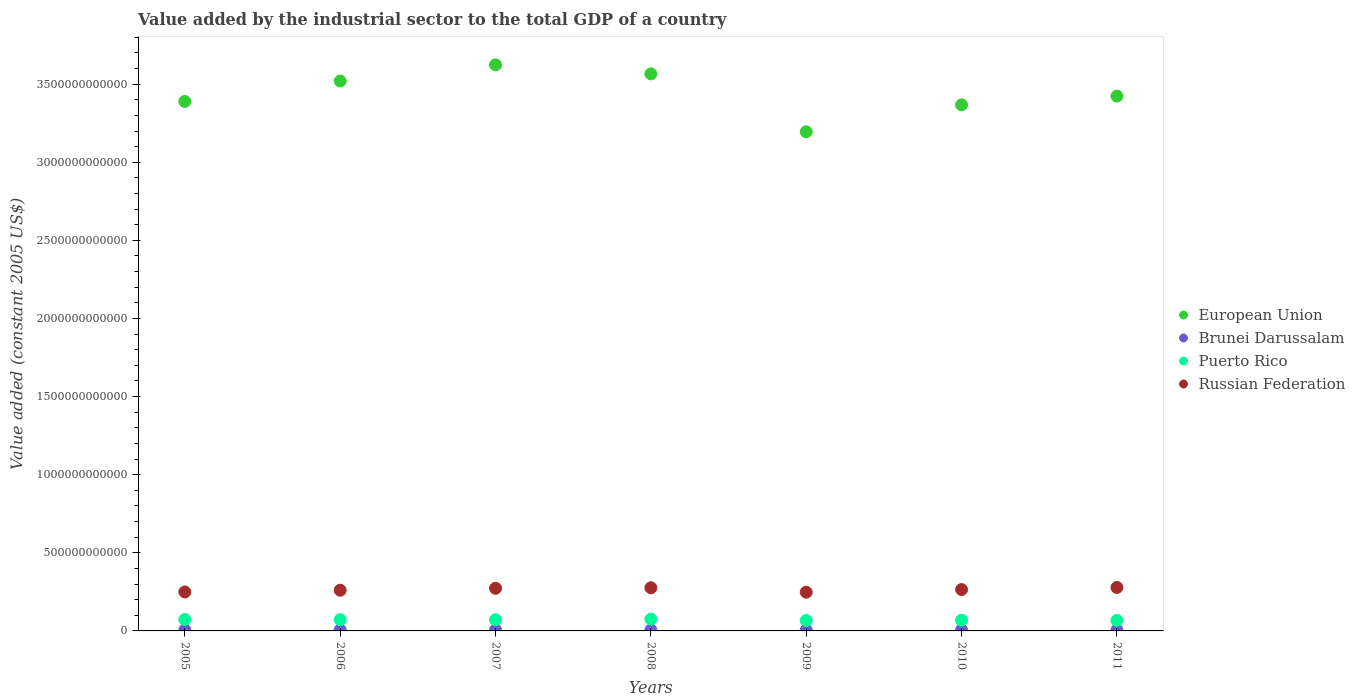What is the value added by the industrial sector in Brunei Darussalam in 2005?
Give a very brief answer. 6.82e+09. Across all years, what is the maximum value added by the industrial sector in Brunei Darussalam?
Offer a very short reply. 7.02e+09. Across all years, what is the minimum value added by the industrial sector in Brunei Darussalam?
Offer a terse response. 5.95e+09. In which year was the value added by the industrial sector in European Union minimum?
Your response must be concise. 2009. What is the total value added by the industrial sector in Puerto Rico in the graph?
Ensure brevity in your answer.  4.94e+11. What is the difference between the value added by the industrial sector in Brunei Darussalam in 2005 and that in 2010?
Give a very brief answer. 7.68e+08. What is the difference between the value added by the industrial sector in Puerto Rico in 2011 and the value added by the industrial sector in European Union in 2007?
Provide a short and direct response. -3.56e+12. What is the average value added by the industrial sector in Brunei Darussalam per year?
Ensure brevity in your answer.  6.42e+09. In the year 2011, what is the difference between the value added by the industrial sector in Russian Federation and value added by the industrial sector in Brunei Darussalam?
Provide a short and direct response. 2.72e+11. In how many years, is the value added by the industrial sector in Brunei Darussalam greater than 3700000000000 US$?
Your response must be concise. 0. What is the ratio of the value added by the industrial sector in European Union in 2008 to that in 2010?
Offer a terse response. 1.06. What is the difference between the highest and the second highest value added by the industrial sector in Russian Federation?
Offer a very short reply. 1.80e+09. What is the difference between the highest and the lowest value added by the industrial sector in Puerto Rico?
Provide a succinct answer. 9.23e+09. In how many years, is the value added by the industrial sector in European Union greater than the average value added by the industrial sector in European Union taken over all years?
Keep it short and to the point. 3. Is the sum of the value added by the industrial sector in Brunei Darussalam in 2008 and 2011 greater than the maximum value added by the industrial sector in Puerto Rico across all years?
Ensure brevity in your answer.  No. Is it the case that in every year, the sum of the value added by the industrial sector in Puerto Rico and value added by the industrial sector in Russian Federation  is greater than the sum of value added by the industrial sector in European Union and value added by the industrial sector in Brunei Darussalam?
Your response must be concise. Yes. Is it the case that in every year, the sum of the value added by the industrial sector in Russian Federation and value added by the industrial sector in European Union  is greater than the value added by the industrial sector in Brunei Darussalam?
Your answer should be very brief. Yes. Is the value added by the industrial sector in Brunei Darussalam strictly greater than the value added by the industrial sector in Puerto Rico over the years?
Keep it short and to the point. No. What is the difference between two consecutive major ticks on the Y-axis?
Your answer should be compact. 5.00e+11. Are the values on the major ticks of Y-axis written in scientific E-notation?
Offer a terse response. No. Does the graph contain any zero values?
Give a very brief answer. No. Does the graph contain grids?
Your answer should be very brief. No. Where does the legend appear in the graph?
Offer a terse response. Center right. How many legend labels are there?
Keep it short and to the point. 4. How are the legend labels stacked?
Make the answer very short. Vertical. What is the title of the graph?
Give a very brief answer. Value added by the industrial sector to the total GDP of a country. What is the label or title of the X-axis?
Provide a succinct answer. Years. What is the label or title of the Y-axis?
Ensure brevity in your answer.  Value added (constant 2005 US$). What is the Value added (constant 2005 US$) of European Union in 2005?
Your response must be concise. 3.39e+12. What is the Value added (constant 2005 US$) in Brunei Darussalam in 2005?
Your answer should be compact. 6.82e+09. What is the Value added (constant 2005 US$) in Puerto Rico in 2005?
Offer a very short reply. 7.31e+1. What is the Value added (constant 2005 US$) of Russian Federation in 2005?
Ensure brevity in your answer.  2.49e+11. What is the Value added (constant 2005 US$) of European Union in 2006?
Keep it short and to the point. 3.52e+12. What is the Value added (constant 2005 US$) in Brunei Darussalam in 2006?
Your answer should be very brief. 7.02e+09. What is the Value added (constant 2005 US$) in Puerto Rico in 2006?
Ensure brevity in your answer.  7.20e+1. What is the Value added (constant 2005 US$) in Russian Federation in 2006?
Your answer should be compact. 2.60e+11. What is the Value added (constant 2005 US$) of European Union in 2007?
Provide a succinct answer. 3.62e+12. What is the Value added (constant 2005 US$) in Brunei Darussalam in 2007?
Your response must be concise. 6.62e+09. What is the Value added (constant 2005 US$) in Puerto Rico in 2007?
Offer a terse response. 7.10e+1. What is the Value added (constant 2005 US$) of Russian Federation in 2007?
Ensure brevity in your answer.  2.73e+11. What is the Value added (constant 2005 US$) of European Union in 2008?
Provide a succinct answer. 3.57e+12. What is the Value added (constant 2005 US$) of Brunei Darussalam in 2008?
Provide a succinct answer. 6.26e+09. What is the Value added (constant 2005 US$) in Puerto Rico in 2008?
Ensure brevity in your answer.  7.57e+1. What is the Value added (constant 2005 US$) in Russian Federation in 2008?
Your answer should be very brief. 2.76e+11. What is the Value added (constant 2005 US$) of European Union in 2009?
Provide a succinct answer. 3.19e+12. What is the Value added (constant 2005 US$) of Brunei Darussalam in 2009?
Offer a very short reply. 5.95e+09. What is the Value added (constant 2005 US$) in Puerto Rico in 2009?
Offer a terse response. 6.65e+1. What is the Value added (constant 2005 US$) of Russian Federation in 2009?
Your response must be concise. 2.48e+11. What is the Value added (constant 2005 US$) of European Union in 2010?
Give a very brief answer. 3.37e+12. What is the Value added (constant 2005 US$) in Brunei Darussalam in 2010?
Provide a short and direct response. 6.05e+09. What is the Value added (constant 2005 US$) of Puerto Rico in 2010?
Your response must be concise. 6.83e+1. What is the Value added (constant 2005 US$) in Russian Federation in 2010?
Your answer should be compact. 2.65e+11. What is the Value added (constant 2005 US$) in European Union in 2011?
Provide a succinct answer. 3.42e+12. What is the Value added (constant 2005 US$) in Brunei Darussalam in 2011?
Provide a short and direct response. 6.25e+09. What is the Value added (constant 2005 US$) of Puerto Rico in 2011?
Make the answer very short. 6.72e+1. What is the Value added (constant 2005 US$) in Russian Federation in 2011?
Provide a succinct answer. 2.78e+11. Across all years, what is the maximum Value added (constant 2005 US$) of European Union?
Your answer should be compact. 3.62e+12. Across all years, what is the maximum Value added (constant 2005 US$) in Brunei Darussalam?
Your answer should be very brief. 7.02e+09. Across all years, what is the maximum Value added (constant 2005 US$) of Puerto Rico?
Offer a very short reply. 7.57e+1. Across all years, what is the maximum Value added (constant 2005 US$) in Russian Federation?
Give a very brief answer. 2.78e+11. Across all years, what is the minimum Value added (constant 2005 US$) of European Union?
Give a very brief answer. 3.19e+12. Across all years, what is the minimum Value added (constant 2005 US$) of Brunei Darussalam?
Give a very brief answer. 5.95e+09. Across all years, what is the minimum Value added (constant 2005 US$) in Puerto Rico?
Your response must be concise. 6.65e+1. Across all years, what is the minimum Value added (constant 2005 US$) of Russian Federation?
Offer a terse response. 2.48e+11. What is the total Value added (constant 2005 US$) of European Union in the graph?
Provide a succinct answer. 2.41e+13. What is the total Value added (constant 2005 US$) of Brunei Darussalam in the graph?
Provide a short and direct response. 4.50e+1. What is the total Value added (constant 2005 US$) of Puerto Rico in the graph?
Provide a short and direct response. 4.94e+11. What is the total Value added (constant 2005 US$) in Russian Federation in the graph?
Your response must be concise. 1.85e+12. What is the difference between the Value added (constant 2005 US$) in European Union in 2005 and that in 2006?
Keep it short and to the point. -1.31e+11. What is the difference between the Value added (constant 2005 US$) in Brunei Darussalam in 2005 and that in 2006?
Your response must be concise. -1.95e+08. What is the difference between the Value added (constant 2005 US$) of Puerto Rico in 2005 and that in 2006?
Offer a terse response. 1.15e+09. What is the difference between the Value added (constant 2005 US$) of Russian Federation in 2005 and that in 2006?
Offer a very short reply. -1.12e+1. What is the difference between the Value added (constant 2005 US$) in European Union in 2005 and that in 2007?
Make the answer very short. -2.35e+11. What is the difference between the Value added (constant 2005 US$) in Brunei Darussalam in 2005 and that in 2007?
Ensure brevity in your answer.  1.96e+08. What is the difference between the Value added (constant 2005 US$) in Puerto Rico in 2005 and that in 2007?
Make the answer very short. 2.08e+09. What is the difference between the Value added (constant 2005 US$) in Russian Federation in 2005 and that in 2007?
Provide a succinct answer. -2.37e+1. What is the difference between the Value added (constant 2005 US$) in European Union in 2005 and that in 2008?
Your answer should be very brief. -1.77e+11. What is the difference between the Value added (constant 2005 US$) in Brunei Darussalam in 2005 and that in 2008?
Give a very brief answer. 5.57e+08. What is the difference between the Value added (constant 2005 US$) in Puerto Rico in 2005 and that in 2008?
Your response must be concise. -2.58e+09. What is the difference between the Value added (constant 2005 US$) in Russian Federation in 2005 and that in 2008?
Offer a terse response. -2.70e+1. What is the difference between the Value added (constant 2005 US$) in European Union in 2005 and that in 2009?
Provide a short and direct response. 1.94e+11. What is the difference between the Value added (constant 2005 US$) in Brunei Darussalam in 2005 and that in 2009?
Provide a succinct answer. 8.71e+08. What is the difference between the Value added (constant 2005 US$) in Puerto Rico in 2005 and that in 2009?
Your answer should be very brief. 6.65e+09. What is the difference between the Value added (constant 2005 US$) of Russian Federation in 2005 and that in 2009?
Make the answer very short. 1.47e+09. What is the difference between the Value added (constant 2005 US$) of European Union in 2005 and that in 2010?
Offer a terse response. 2.17e+1. What is the difference between the Value added (constant 2005 US$) in Brunei Darussalam in 2005 and that in 2010?
Provide a short and direct response. 7.68e+08. What is the difference between the Value added (constant 2005 US$) in Puerto Rico in 2005 and that in 2010?
Ensure brevity in your answer.  4.78e+09. What is the difference between the Value added (constant 2005 US$) of Russian Federation in 2005 and that in 2010?
Give a very brief answer. -1.53e+1. What is the difference between the Value added (constant 2005 US$) of European Union in 2005 and that in 2011?
Your answer should be very brief. -3.43e+1. What is the difference between the Value added (constant 2005 US$) in Brunei Darussalam in 2005 and that in 2011?
Your answer should be compact. 5.75e+08. What is the difference between the Value added (constant 2005 US$) of Puerto Rico in 2005 and that in 2011?
Give a very brief answer. 5.91e+09. What is the difference between the Value added (constant 2005 US$) of Russian Federation in 2005 and that in 2011?
Your answer should be very brief. -2.88e+1. What is the difference between the Value added (constant 2005 US$) in European Union in 2006 and that in 2007?
Your response must be concise. -1.04e+11. What is the difference between the Value added (constant 2005 US$) of Brunei Darussalam in 2006 and that in 2007?
Give a very brief answer. 3.91e+08. What is the difference between the Value added (constant 2005 US$) in Puerto Rico in 2006 and that in 2007?
Keep it short and to the point. 9.25e+08. What is the difference between the Value added (constant 2005 US$) of Russian Federation in 2006 and that in 2007?
Give a very brief answer. -1.25e+1. What is the difference between the Value added (constant 2005 US$) in European Union in 2006 and that in 2008?
Your response must be concise. -4.59e+1. What is the difference between the Value added (constant 2005 US$) of Brunei Darussalam in 2006 and that in 2008?
Keep it short and to the point. 7.51e+08. What is the difference between the Value added (constant 2005 US$) in Puerto Rico in 2006 and that in 2008?
Your answer should be compact. -3.73e+09. What is the difference between the Value added (constant 2005 US$) of Russian Federation in 2006 and that in 2008?
Your answer should be very brief. -1.58e+1. What is the difference between the Value added (constant 2005 US$) of European Union in 2006 and that in 2009?
Your answer should be compact. 3.25e+11. What is the difference between the Value added (constant 2005 US$) in Brunei Darussalam in 2006 and that in 2009?
Provide a succinct answer. 1.07e+09. What is the difference between the Value added (constant 2005 US$) of Puerto Rico in 2006 and that in 2009?
Offer a very short reply. 5.50e+09. What is the difference between the Value added (constant 2005 US$) of Russian Federation in 2006 and that in 2009?
Your answer should be compact. 1.27e+1. What is the difference between the Value added (constant 2005 US$) of European Union in 2006 and that in 2010?
Offer a terse response. 1.53e+11. What is the difference between the Value added (constant 2005 US$) in Brunei Darussalam in 2006 and that in 2010?
Give a very brief answer. 9.63e+08. What is the difference between the Value added (constant 2005 US$) of Puerto Rico in 2006 and that in 2010?
Provide a short and direct response. 3.63e+09. What is the difference between the Value added (constant 2005 US$) in Russian Federation in 2006 and that in 2010?
Give a very brief answer. -4.16e+09. What is the difference between the Value added (constant 2005 US$) in European Union in 2006 and that in 2011?
Provide a short and direct response. 9.66e+1. What is the difference between the Value added (constant 2005 US$) of Brunei Darussalam in 2006 and that in 2011?
Ensure brevity in your answer.  7.70e+08. What is the difference between the Value added (constant 2005 US$) of Puerto Rico in 2006 and that in 2011?
Keep it short and to the point. 4.76e+09. What is the difference between the Value added (constant 2005 US$) in Russian Federation in 2006 and that in 2011?
Your answer should be very brief. -1.76e+1. What is the difference between the Value added (constant 2005 US$) in European Union in 2007 and that in 2008?
Your answer should be very brief. 5.77e+1. What is the difference between the Value added (constant 2005 US$) of Brunei Darussalam in 2007 and that in 2008?
Give a very brief answer. 3.60e+08. What is the difference between the Value added (constant 2005 US$) in Puerto Rico in 2007 and that in 2008?
Make the answer very short. -4.65e+09. What is the difference between the Value added (constant 2005 US$) in Russian Federation in 2007 and that in 2008?
Make the answer very short. -3.32e+09. What is the difference between the Value added (constant 2005 US$) of European Union in 2007 and that in 2009?
Make the answer very short. 4.29e+11. What is the difference between the Value added (constant 2005 US$) of Brunei Darussalam in 2007 and that in 2009?
Provide a short and direct response. 6.75e+08. What is the difference between the Value added (constant 2005 US$) in Puerto Rico in 2007 and that in 2009?
Your answer should be very brief. 4.57e+09. What is the difference between the Value added (constant 2005 US$) in Russian Federation in 2007 and that in 2009?
Provide a short and direct response. 2.52e+1. What is the difference between the Value added (constant 2005 US$) of European Union in 2007 and that in 2010?
Offer a very short reply. 2.56e+11. What is the difference between the Value added (constant 2005 US$) of Brunei Darussalam in 2007 and that in 2010?
Ensure brevity in your answer.  5.72e+08. What is the difference between the Value added (constant 2005 US$) of Puerto Rico in 2007 and that in 2010?
Offer a terse response. 2.70e+09. What is the difference between the Value added (constant 2005 US$) in Russian Federation in 2007 and that in 2010?
Your answer should be compact. 8.37e+09. What is the difference between the Value added (constant 2005 US$) of European Union in 2007 and that in 2011?
Your answer should be very brief. 2.00e+11. What is the difference between the Value added (constant 2005 US$) of Brunei Darussalam in 2007 and that in 2011?
Offer a terse response. 3.79e+08. What is the difference between the Value added (constant 2005 US$) in Puerto Rico in 2007 and that in 2011?
Offer a terse response. 3.84e+09. What is the difference between the Value added (constant 2005 US$) in Russian Federation in 2007 and that in 2011?
Offer a very short reply. -5.12e+09. What is the difference between the Value added (constant 2005 US$) of European Union in 2008 and that in 2009?
Give a very brief answer. 3.71e+11. What is the difference between the Value added (constant 2005 US$) of Brunei Darussalam in 2008 and that in 2009?
Offer a very short reply. 3.14e+08. What is the difference between the Value added (constant 2005 US$) in Puerto Rico in 2008 and that in 2009?
Keep it short and to the point. 9.23e+09. What is the difference between the Value added (constant 2005 US$) in Russian Federation in 2008 and that in 2009?
Make the answer very short. 2.85e+1. What is the difference between the Value added (constant 2005 US$) in European Union in 2008 and that in 2010?
Offer a very short reply. 1.98e+11. What is the difference between the Value added (constant 2005 US$) of Brunei Darussalam in 2008 and that in 2010?
Your response must be concise. 2.12e+08. What is the difference between the Value added (constant 2005 US$) in Puerto Rico in 2008 and that in 2010?
Your answer should be very brief. 7.36e+09. What is the difference between the Value added (constant 2005 US$) in Russian Federation in 2008 and that in 2010?
Give a very brief answer. 1.17e+1. What is the difference between the Value added (constant 2005 US$) of European Union in 2008 and that in 2011?
Offer a very short reply. 1.42e+11. What is the difference between the Value added (constant 2005 US$) in Brunei Darussalam in 2008 and that in 2011?
Your response must be concise. 1.89e+07. What is the difference between the Value added (constant 2005 US$) in Puerto Rico in 2008 and that in 2011?
Your answer should be compact. 8.49e+09. What is the difference between the Value added (constant 2005 US$) in Russian Federation in 2008 and that in 2011?
Provide a short and direct response. -1.80e+09. What is the difference between the Value added (constant 2005 US$) of European Union in 2009 and that in 2010?
Provide a short and direct response. -1.72e+11. What is the difference between the Value added (constant 2005 US$) in Brunei Darussalam in 2009 and that in 2010?
Ensure brevity in your answer.  -1.03e+08. What is the difference between the Value added (constant 2005 US$) of Puerto Rico in 2009 and that in 2010?
Your answer should be compact. -1.87e+09. What is the difference between the Value added (constant 2005 US$) of Russian Federation in 2009 and that in 2010?
Your answer should be compact. -1.68e+1. What is the difference between the Value added (constant 2005 US$) of European Union in 2009 and that in 2011?
Your answer should be very brief. -2.28e+11. What is the difference between the Value added (constant 2005 US$) of Brunei Darussalam in 2009 and that in 2011?
Your answer should be compact. -2.95e+08. What is the difference between the Value added (constant 2005 US$) of Puerto Rico in 2009 and that in 2011?
Your answer should be compact. -7.33e+08. What is the difference between the Value added (constant 2005 US$) in Russian Federation in 2009 and that in 2011?
Offer a very short reply. -3.03e+1. What is the difference between the Value added (constant 2005 US$) in European Union in 2010 and that in 2011?
Your answer should be compact. -5.60e+1. What is the difference between the Value added (constant 2005 US$) in Brunei Darussalam in 2010 and that in 2011?
Offer a very short reply. -1.93e+08. What is the difference between the Value added (constant 2005 US$) in Puerto Rico in 2010 and that in 2011?
Give a very brief answer. 1.13e+09. What is the difference between the Value added (constant 2005 US$) of Russian Federation in 2010 and that in 2011?
Provide a succinct answer. -1.35e+1. What is the difference between the Value added (constant 2005 US$) in European Union in 2005 and the Value added (constant 2005 US$) in Brunei Darussalam in 2006?
Your response must be concise. 3.38e+12. What is the difference between the Value added (constant 2005 US$) in European Union in 2005 and the Value added (constant 2005 US$) in Puerto Rico in 2006?
Make the answer very short. 3.32e+12. What is the difference between the Value added (constant 2005 US$) of European Union in 2005 and the Value added (constant 2005 US$) of Russian Federation in 2006?
Make the answer very short. 3.13e+12. What is the difference between the Value added (constant 2005 US$) in Brunei Darussalam in 2005 and the Value added (constant 2005 US$) in Puerto Rico in 2006?
Make the answer very short. -6.51e+1. What is the difference between the Value added (constant 2005 US$) in Brunei Darussalam in 2005 and the Value added (constant 2005 US$) in Russian Federation in 2006?
Ensure brevity in your answer.  -2.54e+11. What is the difference between the Value added (constant 2005 US$) in Puerto Rico in 2005 and the Value added (constant 2005 US$) in Russian Federation in 2006?
Give a very brief answer. -1.87e+11. What is the difference between the Value added (constant 2005 US$) in European Union in 2005 and the Value added (constant 2005 US$) in Brunei Darussalam in 2007?
Offer a very short reply. 3.38e+12. What is the difference between the Value added (constant 2005 US$) of European Union in 2005 and the Value added (constant 2005 US$) of Puerto Rico in 2007?
Offer a terse response. 3.32e+12. What is the difference between the Value added (constant 2005 US$) of European Union in 2005 and the Value added (constant 2005 US$) of Russian Federation in 2007?
Offer a very short reply. 3.12e+12. What is the difference between the Value added (constant 2005 US$) in Brunei Darussalam in 2005 and the Value added (constant 2005 US$) in Puerto Rico in 2007?
Keep it short and to the point. -6.42e+1. What is the difference between the Value added (constant 2005 US$) of Brunei Darussalam in 2005 and the Value added (constant 2005 US$) of Russian Federation in 2007?
Give a very brief answer. -2.66e+11. What is the difference between the Value added (constant 2005 US$) in Puerto Rico in 2005 and the Value added (constant 2005 US$) in Russian Federation in 2007?
Your response must be concise. -2.00e+11. What is the difference between the Value added (constant 2005 US$) of European Union in 2005 and the Value added (constant 2005 US$) of Brunei Darussalam in 2008?
Your response must be concise. 3.38e+12. What is the difference between the Value added (constant 2005 US$) in European Union in 2005 and the Value added (constant 2005 US$) in Puerto Rico in 2008?
Provide a succinct answer. 3.31e+12. What is the difference between the Value added (constant 2005 US$) in European Union in 2005 and the Value added (constant 2005 US$) in Russian Federation in 2008?
Provide a short and direct response. 3.11e+12. What is the difference between the Value added (constant 2005 US$) in Brunei Darussalam in 2005 and the Value added (constant 2005 US$) in Puerto Rico in 2008?
Keep it short and to the point. -6.89e+1. What is the difference between the Value added (constant 2005 US$) in Brunei Darussalam in 2005 and the Value added (constant 2005 US$) in Russian Federation in 2008?
Give a very brief answer. -2.69e+11. What is the difference between the Value added (constant 2005 US$) in Puerto Rico in 2005 and the Value added (constant 2005 US$) in Russian Federation in 2008?
Ensure brevity in your answer.  -2.03e+11. What is the difference between the Value added (constant 2005 US$) in European Union in 2005 and the Value added (constant 2005 US$) in Brunei Darussalam in 2009?
Your answer should be very brief. 3.38e+12. What is the difference between the Value added (constant 2005 US$) of European Union in 2005 and the Value added (constant 2005 US$) of Puerto Rico in 2009?
Keep it short and to the point. 3.32e+12. What is the difference between the Value added (constant 2005 US$) in European Union in 2005 and the Value added (constant 2005 US$) in Russian Federation in 2009?
Your answer should be very brief. 3.14e+12. What is the difference between the Value added (constant 2005 US$) of Brunei Darussalam in 2005 and the Value added (constant 2005 US$) of Puerto Rico in 2009?
Provide a short and direct response. -5.96e+1. What is the difference between the Value added (constant 2005 US$) of Brunei Darussalam in 2005 and the Value added (constant 2005 US$) of Russian Federation in 2009?
Your response must be concise. -2.41e+11. What is the difference between the Value added (constant 2005 US$) of Puerto Rico in 2005 and the Value added (constant 2005 US$) of Russian Federation in 2009?
Provide a short and direct response. -1.75e+11. What is the difference between the Value added (constant 2005 US$) in European Union in 2005 and the Value added (constant 2005 US$) in Brunei Darussalam in 2010?
Offer a very short reply. 3.38e+12. What is the difference between the Value added (constant 2005 US$) of European Union in 2005 and the Value added (constant 2005 US$) of Puerto Rico in 2010?
Provide a succinct answer. 3.32e+12. What is the difference between the Value added (constant 2005 US$) in European Union in 2005 and the Value added (constant 2005 US$) in Russian Federation in 2010?
Make the answer very short. 3.12e+12. What is the difference between the Value added (constant 2005 US$) in Brunei Darussalam in 2005 and the Value added (constant 2005 US$) in Puerto Rico in 2010?
Offer a very short reply. -6.15e+1. What is the difference between the Value added (constant 2005 US$) of Brunei Darussalam in 2005 and the Value added (constant 2005 US$) of Russian Federation in 2010?
Give a very brief answer. -2.58e+11. What is the difference between the Value added (constant 2005 US$) of Puerto Rico in 2005 and the Value added (constant 2005 US$) of Russian Federation in 2010?
Provide a succinct answer. -1.92e+11. What is the difference between the Value added (constant 2005 US$) in European Union in 2005 and the Value added (constant 2005 US$) in Brunei Darussalam in 2011?
Keep it short and to the point. 3.38e+12. What is the difference between the Value added (constant 2005 US$) in European Union in 2005 and the Value added (constant 2005 US$) in Puerto Rico in 2011?
Offer a very short reply. 3.32e+12. What is the difference between the Value added (constant 2005 US$) in European Union in 2005 and the Value added (constant 2005 US$) in Russian Federation in 2011?
Your answer should be compact. 3.11e+12. What is the difference between the Value added (constant 2005 US$) in Brunei Darussalam in 2005 and the Value added (constant 2005 US$) in Puerto Rico in 2011?
Your answer should be compact. -6.04e+1. What is the difference between the Value added (constant 2005 US$) in Brunei Darussalam in 2005 and the Value added (constant 2005 US$) in Russian Federation in 2011?
Offer a very short reply. -2.71e+11. What is the difference between the Value added (constant 2005 US$) in Puerto Rico in 2005 and the Value added (constant 2005 US$) in Russian Federation in 2011?
Make the answer very short. -2.05e+11. What is the difference between the Value added (constant 2005 US$) of European Union in 2006 and the Value added (constant 2005 US$) of Brunei Darussalam in 2007?
Offer a very short reply. 3.51e+12. What is the difference between the Value added (constant 2005 US$) of European Union in 2006 and the Value added (constant 2005 US$) of Puerto Rico in 2007?
Offer a terse response. 3.45e+12. What is the difference between the Value added (constant 2005 US$) of European Union in 2006 and the Value added (constant 2005 US$) of Russian Federation in 2007?
Keep it short and to the point. 3.25e+12. What is the difference between the Value added (constant 2005 US$) in Brunei Darussalam in 2006 and the Value added (constant 2005 US$) in Puerto Rico in 2007?
Make the answer very short. -6.40e+1. What is the difference between the Value added (constant 2005 US$) of Brunei Darussalam in 2006 and the Value added (constant 2005 US$) of Russian Federation in 2007?
Your response must be concise. -2.66e+11. What is the difference between the Value added (constant 2005 US$) of Puerto Rico in 2006 and the Value added (constant 2005 US$) of Russian Federation in 2007?
Ensure brevity in your answer.  -2.01e+11. What is the difference between the Value added (constant 2005 US$) in European Union in 2006 and the Value added (constant 2005 US$) in Brunei Darussalam in 2008?
Your answer should be compact. 3.51e+12. What is the difference between the Value added (constant 2005 US$) of European Union in 2006 and the Value added (constant 2005 US$) of Puerto Rico in 2008?
Offer a very short reply. 3.44e+12. What is the difference between the Value added (constant 2005 US$) of European Union in 2006 and the Value added (constant 2005 US$) of Russian Federation in 2008?
Keep it short and to the point. 3.24e+12. What is the difference between the Value added (constant 2005 US$) of Brunei Darussalam in 2006 and the Value added (constant 2005 US$) of Puerto Rico in 2008?
Offer a terse response. -6.87e+1. What is the difference between the Value added (constant 2005 US$) in Brunei Darussalam in 2006 and the Value added (constant 2005 US$) in Russian Federation in 2008?
Your answer should be compact. -2.69e+11. What is the difference between the Value added (constant 2005 US$) in Puerto Rico in 2006 and the Value added (constant 2005 US$) in Russian Federation in 2008?
Your response must be concise. -2.04e+11. What is the difference between the Value added (constant 2005 US$) in European Union in 2006 and the Value added (constant 2005 US$) in Brunei Darussalam in 2009?
Your answer should be compact. 3.51e+12. What is the difference between the Value added (constant 2005 US$) in European Union in 2006 and the Value added (constant 2005 US$) in Puerto Rico in 2009?
Ensure brevity in your answer.  3.45e+12. What is the difference between the Value added (constant 2005 US$) in European Union in 2006 and the Value added (constant 2005 US$) in Russian Federation in 2009?
Keep it short and to the point. 3.27e+12. What is the difference between the Value added (constant 2005 US$) in Brunei Darussalam in 2006 and the Value added (constant 2005 US$) in Puerto Rico in 2009?
Provide a succinct answer. -5.95e+1. What is the difference between the Value added (constant 2005 US$) of Brunei Darussalam in 2006 and the Value added (constant 2005 US$) of Russian Federation in 2009?
Provide a short and direct response. -2.41e+11. What is the difference between the Value added (constant 2005 US$) of Puerto Rico in 2006 and the Value added (constant 2005 US$) of Russian Federation in 2009?
Provide a succinct answer. -1.76e+11. What is the difference between the Value added (constant 2005 US$) of European Union in 2006 and the Value added (constant 2005 US$) of Brunei Darussalam in 2010?
Your answer should be compact. 3.51e+12. What is the difference between the Value added (constant 2005 US$) of European Union in 2006 and the Value added (constant 2005 US$) of Puerto Rico in 2010?
Give a very brief answer. 3.45e+12. What is the difference between the Value added (constant 2005 US$) in European Union in 2006 and the Value added (constant 2005 US$) in Russian Federation in 2010?
Give a very brief answer. 3.26e+12. What is the difference between the Value added (constant 2005 US$) of Brunei Darussalam in 2006 and the Value added (constant 2005 US$) of Puerto Rico in 2010?
Ensure brevity in your answer.  -6.13e+1. What is the difference between the Value added (constant 2005 US$) of Brunei Darussalam in 2006 and the Value added (constant 2005 US$) of Russian Federation in 2010?
Your answer should be compact. -2.58e+11. What is the difference between the Value added (constant 2005 US$) in Puerto Rico in 2006 and the Value added (constant 2005 US$) in Russian Federation in 2010?
Make the answer very short. -1.93e+11. What is the difference between the Value added (constant 2005 US$) in European Union in 2006 and the Value added (constant 2005 US$) in Brunei Darussalam in 2011?
Your answer should be compact. 3.51e+12. What is the difference between the Value added (constant 2005 US$) in European Union in 2006 and the Value added (constant 2005 US$) in Puerto Rico in 2011?
Keep it short and to the point. 3.45e+12. What is the difference between the Value added (constant 2005 US$) in European Union in 2006 and the Value added (constant 2005 US$) in Russian Federation in 2011?
Your answer should be compact. 3.24e+12. What is the difference between the Value added (constant 2005 US$) in Brunei Darussalam in 2006 and the Value added (constant 2005 US$) in Puerto Rico in 2011?
Give a very brief answer. -6.02e+1. What is the difference between the Value added (constant 2005 US$) in Brunei Darussalam in 2006 and the Value added (constant 2005 US$) in Russian Federation in 2011?
Keep it short and to the point. -2.71e+11. What is the difference between the Value added (constant 2005 US$) of Puerto Rico in 2006 and the Value added (constant 2005 US$) of Russian Federation in 2011?
Provide a short and direct response. -2.06e+11. What is the difference between the Value added (constant 2005 US$) in European Union in 2007 and the Value added (constant 2005 US$) in Brunei Darussalam in 2008?
Give a very brief answer. 3.62e+12. What is the difference between the Value added (constant 2005 US$) in European Union in 2007 and the Value added (constant 2005 US$) in Puerto Rico in 2008?
Your answer should be very brief. 3.55e+12. What is the difference between the Value added (constant 2005 US$) of European Union in 2007 and the Value added (constant 2005 US$) of Russian Federation in 2008?
Make the answer very short. 3.35e+12. What is the difference between the Value added (constant 2005 US$) of Brunei Darussalam in 2007 and the Value added (constant 2005 US$) of Puerto Rico in 2008?
Your answer should be compact. -6.91e+1. What is the difference between the Value added (constant 2005 US$) in Brunei Darussalam in 2007 and the Value added (constant 2005 US$) in Russian Federation in 2008?
Keep it short and to the point. -2.70e+11. What is the difference between the Value added (constant 2005 US$) in Puerto Rico in 2007 and the Value added (constant 2005 US$) in Russian Federation in 2008?
Offer a very short reply. -2.05e+11. What is the difference between the Value added (constant 2005 US$) in European Union in 2007 and the Value added (constant 2005 US$) in Brunei Darussalam in 2009?
Make the answer very short. 3.62e+12. What is the difference between the Value added (constant 2005 US$) of European Union in 2007 and the Value added (constant 2005 US$) of Puerto Rico in 2009?
Ensure brevity in your answer.  3.56e+12. What is the difference between the Value added (constant 2005 US$) in European Union in 2007 and the Value added (constant 2005 US$) in Russian Federation in 2009?
Make the answer very short. 3.38e+12. What is the difference between the Value added (constant 2005 US$) in Brunei Darussalam in 2007 and the Value added (constant 2005 US$) in Puerto Rico in 2009?
Give a very brief answer. -5.98e+1. What is the difference between the Value added (constant 2005 US$) of Brunei Darussalam in 2007 and the Value added (constant 2005 US$) of Russian Federation in 2009?
Offer a terse response. -2.41e+11. What is the difference between the Value added (constant 2005 US$) in Puerto Rico in 2007 and the Value added (constant 2005 US$) in Russian Federation in 2009?
Provide a short and direct response. -1.77e+11. What is the difference between the Value added (constant 2005 US$) of European Union in 2007 and the Value added (constant 2005 US$) of Brunei Darussalam in 2010?
Provide a short and direct response. 3.62e+12. What is the difference between the Value added (constant 2005 US$) in European Union in 2007 and the Value added (constant 2005 US$) in Puerto Rico in 2010?
Offer a very short reply. 3.56e+12. What is the difference between the Value added (constant 2005 US$) in European Union in 2007 and the Value added (constant 2005 US$) in Russian Federation in 2010?
Make the answer very short. 3.36e+12. What is the difference between the Value added (constant 2005 US$) of Brunei Darussalam in 2007 and the Value added (constant 2005 US$) of Puerto Rico in 2010?
Give a very brief answer. -6.17e+1. What is the difference between the Value added (constant 2005 US$) of Brunei Darussalam in 2007 and the Value added (constant 2005 US$) of Russian Federation in 2010?
Provide a short and direct response. -2.58e+11. What is the difference between the Value added (constant 2005 US$) of Puerto Rico in 2007 and the Value added (constant 2005 US$) of Russian Federation in 2010?
Your answer should be compact. -1.94e+11. What is the difference between the Value added (constant 2005 US$) in European Union in 2007 and the Value added (constant 2005 US$) in Brunei Darussalam in 2011?
Ensure brevity in your answer.  3.62e+12. What is the difference between the Value added (constant 2005 US$) in European Union in 2007 and the Value added (constant 2005 US$) in Puerto Rico in 2011?
Offer a very short reply. 3.56e+12. What is the difference between the Value added (constant 2005 US$) of European Union in 2007 and the Value added (constant 2005 US$) of Russian Federation in 2011?
Your answer should be compact. 3.35e+12. What is the difference between the Value added (constant 2005 US$) of Brunei Darussalam in 2007 and the Value added (constant 2005 US$) of Puerto Rico in 2011?
Offer a terse response. -6.06e+1. What is the difference between the Value added (constant 2005 US$) in Brunei Darussalam in 2007 and the Value added (constant 2005 US$) in Russian Federation in 2011?
Make the answer very short. -2.71e+11. What is the difference between the Value added (constant 2005 US$) in Puerto Rico in 2007 and the Value added (constant 2005 US$) in Russian Federation in 2011?
Your answer should be very brief. -2.07e+11. What is the difference between the Value added (constant 2005 US$) in European Union in 2008 and the Value added (constant 2005 US$) in Brunei Darussalam in 2009?
Give a very brief answer. 3.56e+12. What is the difference between the Value added (constant 2005 US$) of European Union in 2008 and the Value added (constant 2005 US$) of Puerto Rico in 2009?
Your answer should be very brief. 3.50e+12. What is the difference between the Value added (constant 2005 US$) of European Union in 2008 and the Value added (constant 2005 US$) of Russian Federation in 2009?
Ensure brevity in your answer.  3.32e+12. What is the difference between the Value added (constant 2005 US$) of Brunei Darussalam in 2008 and the Value added (constant 2005 US$) of Puerto Rico in 2009?
Offer a terse response. -6.02e+1. What is the difference between the Value added (constant 2005 US$) in Brunei Darussalam in 2008 and the Value added (constant 2005 US$) in Russian Federation in 2009?
Make the answer very short. -2.42e+11. What is the difference between the Value added (constant 2005 US$) in Puerto Rico in 2008 and the Value added (constant 2005 US$) in Russian Federation in 2009?
Ensure brevity in your answer.  -1.72e+11. What is the difference between the Value added (constant 2005 US$) of European Union in 2008 and the Value added (constant 2005 US$) of Brunei Darussalam in 2010?
Provide a succinct answer. 3.56e+12. What is the difference between the Value added (constant 2005 US$) in European Union in 2008 and the Value added (constant 2005 US$) in Puerto Rico in 2010?
Your answer should be very brief. 3.50e+12. What is the difference between the Value added (constant 2005 US$) of European Union in 2008 and the Value added (constant 2005 US$) of Russian Federation in 2010?
Offer a terse response. 3.30e+12. What is the difference between the Value added (constant 2005 US$) of Brunei Darussalam in 2008 and the Value added (constant 2005 US$) of Puerto Rico in 2010?
Your response must be concise. -6.21e+1. What is the difference between the Value added (constant 2005 US$) in Brunei Darussalam in 2008 and the Value added (constant 2005 US$) in Russian Federation in 2010?
Your answer should be compact. -2.58e+11. What is the difference between the Value added (constant 2005 US$) of Puerto Rico in 2008 and the Value added (constant 2005 US$) of Russian Federation in 2010?
Provide a short and direct response. -1.89e+11. What is the difference between the Value added (constant 2005 US$) of European Union in 2008 and the Value added (constant 2005 US$) of Brunei Darussalam in 2011?
Offer a terse response. 3.56e+12. What is the difference between the Value added (constant 2005 US$) of European Union in 2008 and the Value added (constant 2005 US$) of Puerto Rico in 2011?
Your response must be concise. 3.50e+12. What is the difference between the Value added (constant 2005 US$) in European Union in 2008 and the Value added (constant 2005 US$) in Russian Federation in 2011?
Your answer should be very brief. 3.29e+12. What is the difference between the Value added (constant 2005 US$) of Brunei Darussalam in 2008 and the Value added (constant 2005 US$) of Puerto Rico in 2011?
Offer a terse response. -6.09e+1. What is the difference between the Value added (constant 2005 US$) in Brunei Darussalam in 2008 and the Value added (constant 2005 US$) in Russian Federation in 2011?
Your response must be concise. -2.72e+11. What is the difference between the Value added (constant 2005 US$) of Puerto Rico in 2008 and the Value added (constant 2005 US$) of Russian Federation in 2011?
Provide a short and direct response. -2.02e+11. What is the difference between the Value added (constant 2005 US$) in European Union in 2009 and the Value added (constant 2005 US$) in Brunei Darussalam in 2010?
Make the answer very short. 3.19e+12. What is the difference between the Value added (constant 2005 US$) in European Union in 2009 and the Value added (constant 2005 US$) in Puerto Rico in 2010?
Provide a short and direct response. 3.13e+12. What is the difference between the Value added (constant 2005 US$) of European Union in 2009 and the Value added (constant 2005 US$) of Russian Federation in 2010?
Provide a succinct answer. 2.93e+12. What is the difference between the Value added (constant 2005 US$) in Brunei Darussalam in 2009 and the Value added (constant 2005 US$) in Puerto Rico in 2010?
Your response must be concise. -6.24e+1. What is the difference between the Value added (constant 2005 US$) of Brunei Darussalam in 2009 and the Value added (constant 2005 US$) of Russian Federation in 2010?
Offer a very short reply. -2.59e+11. What is the difference between the Value added (constant 2005 US$) in Puerto Rico in 2009 and the Value added (constant 2005 US$) in Russian Federation in 2010?
Your answer should be very brief. -1.98e+11. What is the difference between the Value added (constant 2005 US$) of European Union in 2009 and the Value added (constant 2005 US$) of Brunei Darussalam in 2011?
Provide a succinct answer. 3.19e+12. What is the difference between the Value added (constant 2005 US$) of European Union in 2009 and the Value added (constant 2005 US$) of Puerto Rico in 2011?
Your answer should be very brief. 3.13e+12. What is the difference between the Value added (constant 2005 US$) of European Union in 2009 and the Value added (constant 2005 US$) of Russian Federation in 2011?
Offer a very short reply. 2.92e+12. What is the difference between the Value added (constant 2005 US$) in Brunei Darussalam in 2009 and the Value added (constant 2005 US$) in Puerto Rico in 2011?
Offer a terse response. -6.13e+1. What is the difference between the Value added (constant 2005 US$) of Brunei Darussalam in 2009 and the Value added (constant 2005 US$) of Russian Federation in 2011?
Give a very brief answer. -2.72e+11. What is the difference between the Value added (constant 2005 US$) in Puerto Rico in 2009 and the Value added (constant 2005 US$) in Russian Federation in 2011?
Your answer should be very brief. -2.12e+11. What is the difference between the Value added (constant 2005 US$) of European Union in 2010 and the Value added (constant 2005 US$) of Brunei Darussalam in 2011?
Give a very brief answer. 3.36e+12. What is the difference between the Value added (constant 2005 US$) in European Union in 2010 and the Value added (constant 2005 US$) in Puerto Rico in 2011?
Your answer should be very brief. 3.30e+12. What is the difference between the Value added (constant 2005 US$) of European Union in 2010 and the Value added (constant 2005 US$) of Russian Federation in 2011?
Offer a very short reply. 3.09e+12. What is the difference between the Value added (constant 2005 US$) of Brunei Darussalam in 2010 and the Value added (constant 2005 US$) of Puerto Rico in 2011?
Provide a succinct answer. -6.11e+1. What is the difference between the Value added (constant 2005 US$) in Brunei Darussalam in 2010 and the Value added (constant 2005 US$) in Russian Federation in 2011?
Offer a terse response. -2.72e+11. What is the difference between the Value added (constant 2005 US$) of Puerto Rico in 2010 and the Value added (constant 2005 US$) of Russian Federation in 2011?
Make the answer very short. -2.10e+11. What is the average Value added (constant 2005 US$) in European Union per year?
Your answer should be very brief. 3.44e+12. What is the average Value added (constant 2005 US$) of Brunei Darussalam per year?
Offer a very short reply. 6.42e+09. What is the average Value added (constant 2005 US$) in Puerto Rico per year?
Your response must be concise. 7.05e+1. What is the average Value added (constant 2005 US$) of Russian Federation per year?
Keep it short and to the point. 2.64e+11. In the year 2005, what is the difference between the Value added (constant 2005 US$) in European Union and Value added (constant 2005 US$) in Brunei Darussalam?
Your answer should be compact. 3.38e+12. In the year 2005, what is the difference between the Value added (constant 2005 US$) in European Union and Value added (constant 2005 US$) in Puerto Rico?
Your answer should be very brief. 3.32e+12. In the year 2005, what is the difference between the Value added (constant 2005 US$) of European Union and Value added (constant 2005 US$) of Russian Federation?
Your answer should be very brief. 3.14e+12. In the year 2005, what is the difference between the Value added (constant 2005 US$) in Brunei Darussalam and Value added (constant 2005 US$) in Puerto Rico?
Offer a terse response. -6.63e+1. In the year 2005, what is the difference between the Value added (constant 2005 US$) in Brunei Darussalam and Value added (constant 2005 US$) in Russian Federation?
Your answer should be very brief. -2.42e+11. In the year 2005, what is the difference between the Value added (constant 2005 US$) of Puerto Rico and Value added (constant 2005 US$) of Russian Federation?
Offer a very short reply. -1.76e+11. In the year 2006, what is the difference between the Value added (constant 2005 US$) of European Union and Value added (constant 2005 US$) of Brunei Darussalam?
Your response must be concise. 3.51e+12. In the year 2006, what is the difference between the Value added (constant 2005 US$) of European Union and Value added (constant 2005 US$) of Puerto Rico?
Your answer should be compact. 3.45e+12. In the year 2006, what is the difference between the Value added (constant 2005 US$) of European Union and Value added (constant 2005 US$) of Russian Federation?
Offer a terse response. 3.26e+12. In the year 2006, what is the difference between the Value added (constant 2005 US$) of Brunei Darussalam and Value added (constant 2005 US$) of Puerto Rico?
Your answer should be very brief. -6.49e+1. In the year 2006, what is the difference between the Value added (constant 2005 US$) of Brunei Darussalam and Value added (constant 2005 US$) of Russian Federation?
Give a very brief answer. -2.53e+11. In the year 2006, what is the difference between the Value added (constant 2005 US$) of Puerto Rico and Value added (constant 2005 US$) of Russian Federation?
Give a very brief answer. -1.89e+11. In the year 2007, what is the difference between the Value added (constant 2005 US$) of European Union and Value added (constant 2005 US$) of Brunei Darussalam?
Provide a short and direct response. 3.62e+12. In the year 2007, what is the difference between the Value added (constant 2005 US$) of European Union and Value added (constant 2005 US$) of Puerto Rico?
Ensure brevity in your answer.  3.55e+12. In the year 2007, what is the difference between the Value added (constant 2005 US$) of European Union and Value added (constant 2005 US$) of Russian Federation?
Your response must be concise. 3.35e+12. In the year 2007, what is the difference between the Value added (constant 2005 US$) of Brunei Darussalam and Value added (constant 2005 US$) of Puerto Rico?
Offer a terse response. -6.44e+1. In the year 2007, what is the difference between the Value added (constant 2005 US$) in Brunei Darussalam and Value added (constant 2005 US$) in Russian Federation?
Your answer should be compact. -2.66e+11. In the year 2007, what is the difference between the Value added (constant 2005 US$) of Puerto Rico and Value added (constant 2005 US$) of Russian Federation?
Offer a very short reply. -2.02e+11. In the year 2008, what is the difference between the Value added (constant 2005 US$) in European Union and Value added (constant 2005 US$) in Brunei Darussalam?
Offer a terse response. 3.56e+12. In the year 2008, what is the difference between the Value added (constant 2005 US$) in European Union and Value added (constant 2005 US$) in Puerto Rico?
Offer a very short reply. 3.49e+12. In the year 2008, what is the difference between the Value added (constant 2005 US$) of European Union and Value added (constant 2005 US$) of Russian Federation?
Your response must be concise. 3.29e+12. In the year 2008, what is the difference between the Value added (constant 2005 US$) in Brunei Darussalam and Value added (constant 2005 US$) in Puerto Rico?
Ensure brevity in your answer.  -6.94e+1. In the year 2008, what is the difference between the Value added (constant 2005 US$) of Brunei Darussalam and Value added (constant 2005 US$) of Russian Federation?
Give a very brief answer. -2.70e+11. In the year 2008, what is the difference between the Value added (constant 2005 US$) in Puerto Rico and Value added (constant 2005 US$) in Russian Federation?
Offer a terse response. -2.01e+11. In the year 2009, what is the difference between the Value added (constant 2005 US$) of European Union and Value added (constant 2005 US$) of Brunei Darussalam?
Offer a very short reply. 3.19e+12. In the year 2009, what is the difference between the Value added (constant 2005 US$) of European Union and Value added (constant 2005 US$) of Puerto Rico?
Your answer should be very brief. 3.13e+12. In the year 2009, what is the difference between the Value added (constant 2005 US$) in European Union and Value added (constant 2005 US$) in Russian Federation?
Provide a short and direct response. 2.95e+12. In the year 2009, what is the difference between the Value added (constant 2005 US$) of Brunei Darussalam and Value added (constant 2005 US$) of Puerto Rico?
Your answer should be very brief. -6.05e+1. In the year 2009, what is the difference between the Value added (constant 2005 US$) in Brunei Darussalam and Value added (constant 2005 US$) in Russian Federation?
Your response must be concise. -2.42e+11. In the year 2009, what is the difference between the Value added (constant 2005 US$) of Puerto Rico and Value added (constant 2005 US$) of Russian Federation?
Your answer should be compact. -1.81e+11. In the year 2010, what is the difference between the Value added (constant 2005 US$) of European Union and Value added (constant 2005 US$) of Brunei Darussalam?
Offer a terse response. 3.36e+12. In the year 2010, what is the difference between the Value added (constant 2005 US$) of European Union and Value added (constant 2005 US$) of Puerto Rico?
Provide a succinct answer. 3.30e+12. In the year 2010, what is the difference between the Value added (constant 2005 US$) of European Union and Value added (constant 2005 US$) of Russian Federation?
Your answer should be compact. 3.10e+12. In the year 2010, what is the difference between the Value added (constant 2005 US$) in Brunei Darussalam and Value added (constant 2005 US$) in Puerto Rico?
Provide a short and direct response. -6.23e+1. In the year 2010, what is the difference between the Value added (constant 2005 US$) in Brunei Darussalam and Value added (constant 2005 US$) in Russian Federation?
Your response must be concise. -2.59e+11. In the year 2010, what is the difference between the Value added (constant 2005 US$) of Puerto Rico and Value added (constant 2005 US$) of Russian Federation?
Offer a terse response. -1.96e+11. In the year 2011, what is the difference between the Value added (constant 2005 US$) of European Union and Value added (constant 2005 US$) of Brunei Darussalam?
Provide a short and direct response. 3.42e+12. In the year 2011, what is the difference between the Value added (constant 2005 US$) of European Union and Value added (constant 2005 US$) of Puerto Rico?
Make the answer very short. 3.36e+12. In the year 2011, what is the difference between the Value added (constant 2005 US$) of European Union and Value added (constant 2005 US$) of Russian Federation?
Your answer should be very brief. 3.15e+12. In the year 2011, what is the difference between the Value added (constant 2005 US$) of Brunei Darussalam and Value added (constant 2005 US$) of Puerto Rico?
Offer a terse response. -6.10e+1. In the year 2011, what is the difference between the Value added (constant 2005 US$) of Brunei Darussalam and Value added (constant 2005 US$) of Russian Federation?
Provide a short and direct response. -2.72e+11. In the year 2011, what is the difference between the Value added (constant 2005 US$) of Puerto Rico and Value added (constant 2005 US$) of Russian Federation?
Offer a very short reply. -2.11e+11. What is the ratio of the Value added (constant 2005 US$) in European Union in 2005 to that in 2006?
Provide a short and direct response. 0.96. What is the ratio of the Value added (constant 2005 US$) of Brunei Darussalam in 2005 to that in 2006?
Keep it short and to the point. 0.97. What is the ratio of the Value added (constant 2005 US$) in Puerto Rico in 2005 to that in 2006?
Your answer should be very brief. 1.02. What is the ratio of the Value added (constant 2005 US$) in Russian Federation in 2005 to that in 2006?
Offer a terse response. 0.96. What is the ratio of the Value added (constant 2005 US$) of European Union in 2005 to that in 2007?
Offer a terse response. 0.94. What is the ratio of the Value added (constant 2005 US$) of Brunei Darussalam in 2005 to that in 2007?
Ensure brevity in your answer.  1.03. What is the ratio of the Value added (constant 2005 US$) in Puerto Rico in 2005 to that in 2007?
Make the answer very short. 1.03. What is the ratio of the Value added (constant 2005 US$) in Russian Federation in 2005 to that in 2007?
Your answer should be compact. 0.91. What is the ratio of the Value added (constant 2005 US$) of European Union in 2005 to that in 2008?
Keep it short and to the point. 0.95. What is the ratio of the Value added (constant 2005 US$) in Brunei Darussalam in 2005 to that in 2008?
Make the answer very short. 1.09. What is the ratio of the Value added (constant 2005 US$) in Puerto Rico in 2005 to that in 2008?
Ensure brevity in your answer.  0.97. What is the ratio of the Value added (constant 2005 US$) of Russian Federation in 2005 to that in 2008?
Offer a very short reply. 0.9. What is the ratio of the Value added (constant 2005 US$) in European Union in 2005 to that in 2009?
Offer a terse response. 1.06. What is the ratio of the Value added (constant 2005 US$) of Brunei Darussalam in 2005 to that in 2009?
Ensure brevity in your answer.  1.15. What is the ratio of the Value added (constant 2005 US$) of Russian Federation in 2005 to that in 2009?
Your answer should be very brief. 1.01. What is the ratio of the Value added (constant 2005 US$) in European Union in 2005 to that in 2010?
Keep it short and to the point. 1.01. What is the ratio of the Value added (constant 2005 US$) in Brunei Darussalam in 2005 to that in 2010?
Keep it short and to the point. 1.13. What is the ratio of the Value added (constant 2005 US$) in Puerto Rico in 2005 to that in 2010?
Provide a succinct answer. 1.07. What is the ratio of the Value added (constant 2005 US$) of Russian Federation in 2005 to that in 2010?
Give a very brief answer. 0.94. What is the ratio of the Value added (constant 2005 US$) of Brunei Darussalam in 2005 to that in 2011?
Ensure brevity in your answer.  1.09. What is the ratio of the Value added (constant 2005 US$) of Puerto Rico in 2005 to that in 2011?
Offer a very short reply. 1.09. What is the ratio of the Value added (constant 2005 US$) of Russian Federation in 2005 to that in 2011?
Offer a terse response. 0.9. What is the ratio of the Value added (constant 2005 US$) of European Union in 2006 to that in 2007?
Make the answer very short. 0.97. What is the ratio of the Value added (constant 2005 US$) in Brunei Darussalam in 2006 to that in 2007?
Ensure brevity in your answer.  1.06. What is the ratio of the Value added (constant 2005 US$) in Russian Federation in 2006 to that in 2007?
Give a very brief answer. 0.95. What is the ratio of the Value added (constant 2005 US$) in European Union in 2006 to that in 2008?
Provide a short and direct response. 0.99. What is the ratio of the Value added (constant 2005 US$) of Brunei Darussalam in 2006 to that in 2008?
Ensure brevity in your answer.  1.12. What is the ratio of the Value added (constant 2005 US$) in Puerto Rico in 2006 to that in 2008?
Give a very brief answer. 0.95. What is the ratio of the Value added (constant 2005 US$) in Russian Federation in 2006 to that in 2008?
Make the answer very short. 0.94. What is the ratio of the Value added (constant 2005 US$) in European Union in 2006 to that in 2009?
Your answer should be compact. 1.1. What is the ratio of the Value added (constant 2005 US$) in Brunei Darussalam in 2006 to that in 2009?
Keep it short and to the point. 1.18. What is the ratio of the Value added (constant 2005 US$) in Puerto Rico in 2006 to that in 2009?
Ensure brevity in your answer.  1.08. What is the ratio of the Value added (constant 2005 US$) in Russian Federation in 2006 to that in 2009?
Your answer should be very brief. 1.05. What is the ratio of the Value added (constant 2005 US$) of European Union in 2006 to that in 2010?
Provide a succinct answer. 1.05. What is the ratio of the Value added (constant 2005 US$) of Brunei Darussalam in 2006 to that in 2010?
Your answer should be compact. 1.16. What is the ratio of the Value added (constant 2005 US$) in Puerto Rico in 2006 to that in 2010?
Your answer should be compact. 1.05. What is the ratio of the Value added (constant 2005 US$) in Russian Federation in 2006 to that in 2010?
Offer a terse response. 0.98. What is the ratio of the Value added (constant 2005 US$) in European Union in 2006 to that in 2011?
Make the answer very short. 1.03. What is the ratio of the Value added (constant 2005 US$) of Brunei Darussalam in 2006 to that in 2011?
Keep it short and to the point. 1.12. What is the ratio of the Value added (constant 2005 US$) of Puerto Rico in 2006 to that in 2011?
Ensure brevity in your answer.  1.07. What is the ratio of the Value added (constant 2005 US$) in Russian Federation in 2006 to that in 2011?
Keep it short and to the point. 0.94. What is the ratio of the Value added (constant 2005 US$) in European Union in 2007 to that in 2008?
Offer a very short reply. 1.02. What is the ratio of the Value added (constant 2005 US$) in Brunei Darussalam in 2007 to that in 2008?
Provide a short and direct response. 1.06. What is the ratio of the Value added (constant 2005 US$) in Puerto Rico in 2007 to that in 2008?
Offer a terse response. 0.94. What is the ratio of the Value added (constant 2005 US$) of European Union in 2007 to that in 2009?
Give a very brief answer. 1.13. What is the ratio of the Value added (constant 2005 US$) in Brunei Darussalam in 2007 to that in 2009?
Offer a terse response. 1.11. What is the ratio of the Value added (constant 2005 US$) in Puerto Rico in 2007 to that in 2009?
Your response must be concise. 1.07. What is the ratio of the Value added (constant 2005 US$) in Russian Federation in 2007 to that in 2009?
Ensure brevity in your answer.  1.1. What is the ratio of the Value added (constant 2005 US$) in European Union in 2007 to that in 2010?
Keep it short and to the point. 1.08. What is the ratio of the Value added (constant 2005 US$) of Brunei Darussalam in 2007 to that in 2010?
Provide a short and direct response. 1.09. What is the ratio of the Value added (constant 2005 US$) in Puerto Rico in 2007 to that in 2010?
Your response must be concise. 1.04. What is the ratio of the Value added (constant 2005 US$) in Russian Federation in 2007 to that in 2010?
Provide a succinct answer. 1.03. What is the ratio of the Value added (constant 2005 US$) of European Union in 2007 to that in 2011?
Make the answer very short. 1.06. What is the ratio of the Value added (constant 2005 US$) in Brunei Darussalam in 2007 to that in 2011?
Make the answer very short. 1.06. What is the ratio of the Value added (constant 2005 US$) in Puerto Rico in 2007 to that in 2011?
Your answer should be very brief. 1.06. What is the ratio of the Value added (constant 2005 US$) of Russian Federation in 2007 to that in 2011?
Give a very brief answer. 0.98. What is the ratio of the Value added (constant 2005 US$) of European Union in 2008 to that in 2009?
Your answer should be very brief. 1.12. What is the ratio of the Value added (constant 2005 US$) in Brunei Darussalam in 2008 to that in 2009?
Ensure brevity in your answer.  1.05. What is the ratio of the Value added (constant 2005 US$) of Puerto Rico in 2008 to that in 2009?
Offer a terse response. 1.14. What is the ratio of the Value added (constant 2005 US$) of Russian Federation in 2008 to that in 2009?
Your response must be concise. 1.11. What is the ratio of the Value added (constant 2005 US$) of European Union in 2008 to that in 2010?
Keep it short and to the point. 1.06. What is the ratio of the Value added (constant 2005 US$) in Brunei Darussalam in 2008 to that in 2010?
Give a very brief answer. 1.03. What is the ratio of the Value added (constant 2005 US$) in Puerto Rico in 2008 to that in 2010?
Your answer should be very brief. 1.11. What is the ratio of the Value added (constant 2005 US$) of Russian Federation in 2008 to that in 2010?
Give a very brief answer. 1.04. What is the ratio of the Value added (constant 2005 US$) in European Union in 2008 to that in 2011?
Your answer should be very brief. 1.04. What is the ratio of the Value added (constant 2005 US$) of Brunei Darussalam in 2008 to that in 2011?
Provide a short and direct response. 1. What is the ratio of the Value added (constant 2005 US$) in Puerto Rico in 2008 to that in 2011?
Make the answer very short. 1.13. What is the ratio of the Value added (constant 2005 US$) of European Union in 2009 to that in 2010?
Your response must be concise. 0.95. What is the ratio of the Value added (constant 2005 US$) of Puerto Rico in 2009 to that in 2010?
Your answer should be compact. 0.97. What is the ratio of the Value added (constant 2005 US$) in Russian Federation in 2009 to that in 2010?
Offer a terse response. 0.94. What is the ratio of the Value added (constant 2005 US$) in Brunei Darussalam in 2009 to that in 2011?
Make the answer very short. 0.95. What is the ratio of the Value added (constant 2005 US$) in Puerto Rico in 2009 to that in 2011?
Your answer should be very brief. 0.99. What is the ratio of the Value added (constant 2005 US$) of Russian Federation in 2009 to that in 2011?
Your response must be concise. 0.89. What is the ratio of the Value added (constant 2005 US$) of European Union in 2010 to that in 2011?
Offer a terse response. 0.98. What is the ratio of the Value added (constant 2005 US$) in Brunei Darussalam in 2010 to that in 2011?
Keep it short and to the point. 0.97. What is the ratio of the Value added (constant 2005 US$) of Puerto Rico in 2010 to that in 2011?
Keep it short and to the point. 1.02. What is the ratio of the Value added (constant 2005 US$) of Russian Federation in 2010 to that in 2011?
Make the answer very short. 0.95. What is the difference between the highest and the second highest Value added (constant 2005 US$) of European Union?
Your answer should be compact. 5.77e+1. What is the difference between the highest and the second highest Value added (constant 2005 US$) in Brunei Darussalam?
Offer a very short reply. 1.95e+08. What is the difference between the highest and the second highest Value added (constant 2005 US$) in Puerto Rico?
Provide a succinct answer. 2.58e+09. What is the difference between the highest and the second highest Value added (constant 2005 US$) of Russian Federation?
Provide a short and direct response. 1.80e+09. What is the difference between the highest and the lowest Value added (constant 2005 US$) in European Union?
Keep it short and to the point. 4.29e+11. What is the difference between the highest and the lowest Value added (constant 2005 US$) of Brunei Darussalam?
Provide a short and direct response. 1.07e+09. What is the difference between the highest and the lowest Value added (constant 2005 US$) in Puerto Rico?
Your answer should be compact. 9.23e+09. What is the difference between the highest and the lowest Value added (constant 2005 US$) in Russian Federation?
Ensure brevity in your answer.  3.03e+1. 